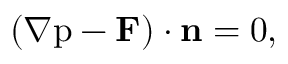Convert formula to latex. <formula><loc_0><loc_0><loc_500><loc_500>( { \nabla p - { F } ) \cdot { n } = 0 } ,</formula> 